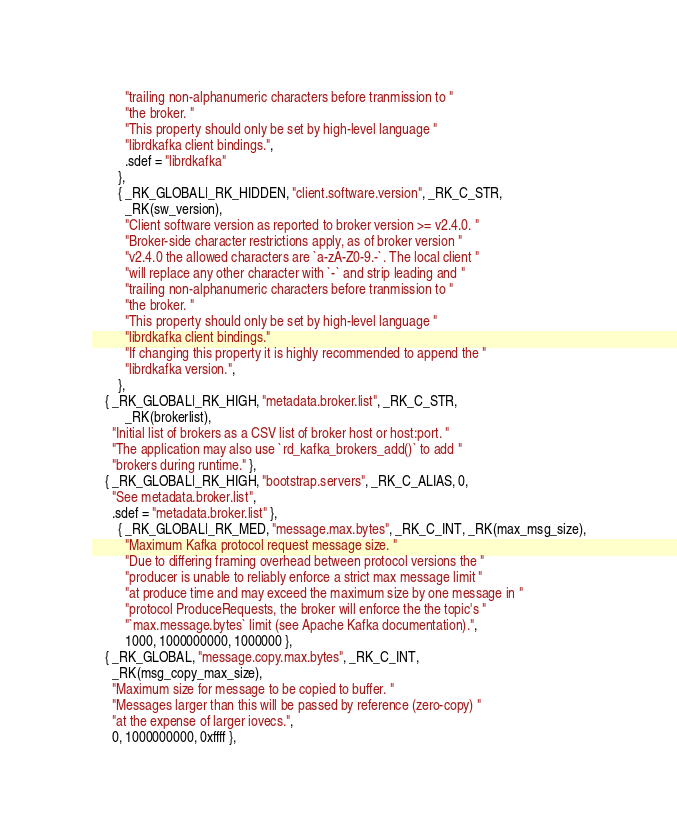<code> <loc_0><loc_0><loc_500><loc_500><_C_>          "trailing non-alphanumeric characters before tranmission to "
          "the broker. "
          "This property should only be set by high-level language "
          "librdkafka client bindings.",
          .sdef = "librdkafka"
        },
        { _RK_GLOBAL|_RK_HIDDEN, "client.software.version", _RK_C_STR,
          _RK(sw_version),
          "Client software version as reported to broker version >= v2.4.0. "
          "Broker-side character restrictions apply, as of broker version "
          "v2.4.0 the allowed characters are `a-zA-Z0-9.-`. The local client "
          "will replace any other character with `-` and strip leading and "
          "trailing non-alphanumeric characters before tranmission to "
          "the broker. "
          "This property should only be set by high-level language "
          "librdkafka client bindings."
          "If changing this property it is highly recommended to append the "
          "librdkafka version.",
        },
	{ _RK_GLOBAL|_RK_HIGH, "metadata.broker.list", _RK_C_STR,
          _RK(brokerlist),
	  "Initial list of brokers as a CSV list of broker host or host:port. "
	  "The application may also use `rd_kafka_brokers_add()` to add "
	  "brokers during runtime." },
	{ _RK_GLOBAL|_RK_HIGH, "bootstrap.servers", _RK_C_ALIAS, 0,
	  "See metadata.broker.list",
	  .sdef = "metadata.broker.list" },
        { _RK_GLOBAL|_RK_MED, "message.max.bytes", _RK_C_INT, _RK(max_msg_size),
          "Maximum Kafka protocol request message size. "
          "Due to differing framing overhead between protocol versions the "
          "producer is unable to reliably enforce a strict max message limit "
          "at produce time and may exceed the maximum size by one message in "
          "protocol ProduceRequests, the broker will enforce the the topic's "
          "`max.message.bytes` limit (see Apache Kafka documentation).",
          1000, 1000000000, 1000000 },
	{ _RK_GLOBAL, "message.copy.max.bytes", _RK_C_INT,
	  _RK(msg_copy_max_size),
	  "Maximum size for message to be copied to buffer. "
	  "Messages larger than this will be passed by reference (zero-copy) "
	  "at the expense of larger iovecs.",
	  0, 1000000000, 0xffff },</code> 